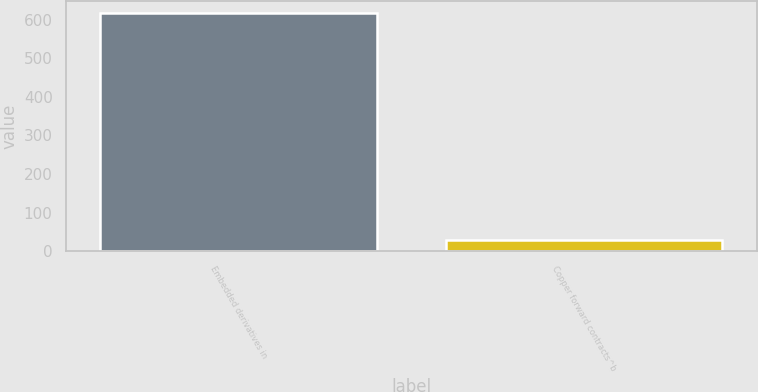<chart> <loc_0><loc_0><loc_500><loc_500><bar_chart><fcel>Embedded derivatives in<fcel>Copper forward contracts^b<nl><fcel>619<fcel>30<nl></chart> 